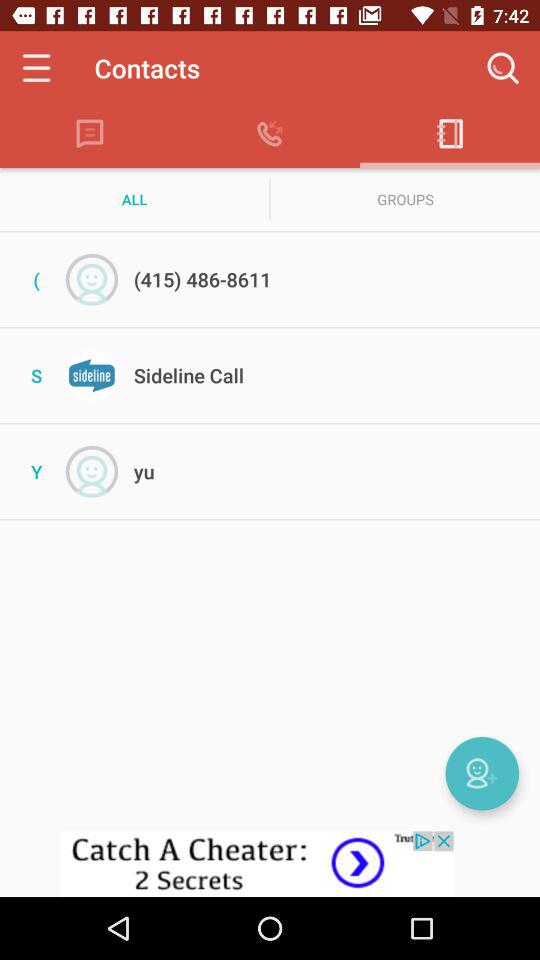What is the contact number? The contact number is (415) 486-8611. 